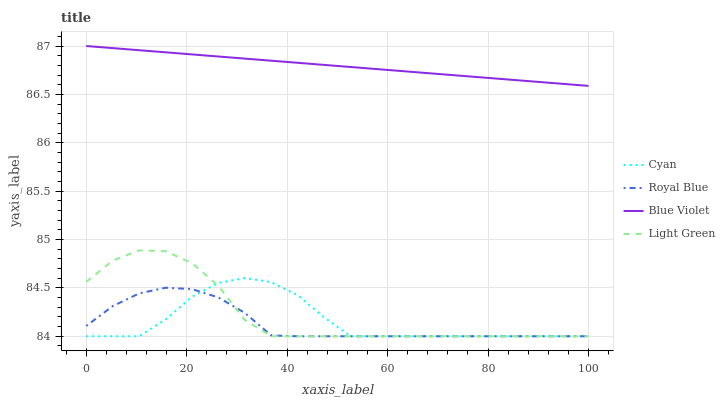Does Royal Blue have the minimum area under the curve?
Answer yes or no. Yes. Does Blue Violet have the maximum area under the curve?
Answer yes or no. Yes. Does Light Green have the minimum area under the curve?
Answer yes or no. No. Does Light Green have the maximum area under the curve?
Answer yes or no. No. Is Blue Violet the smoothest?
Answer yes or no. Yes. Is Cyan the roughest?
Answer yes or no. Yes. Is Light Green the smoothest?
Answer yes or no. No. Is Light Green the roughest?
Answer yes or no. No. Does Cyan have the lowest value?
Answer yes or no. Yes. Does Blue Violet have the lowest value?
Answer yes or no. No. Does Blue Violet have the highest value?
Answer yes or no. Yes. Does Light Green have the highest value?
Answer yes or no. No. Is Light Green less than Blue Violet?
Answer yes or no. Yes. Is Blue Violet greater than Royal Blue?
Answer yes or no. Yes. Does Cyan intersect Royal Blue?
Answer yes or no. Yes. Is Cyan less than Royal Blue?
Answer yes or no. No. Is Cyan greater than Royal Blue?
Answer yes or no. No. Does Light Green intersect Blue Violet?
Answer yes or no. No. 